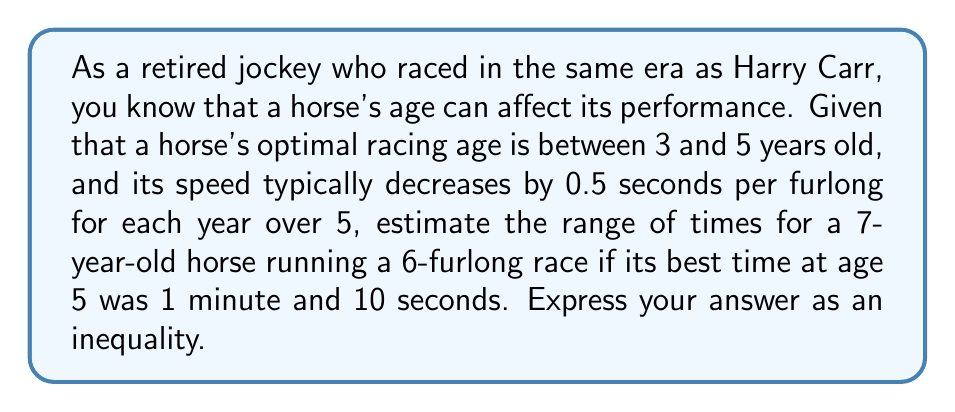What is the answer to this math problem? Let's approach this step-by-step:

1) First, we need to convert the original time to seconds:
   1 minute and 10 seconds = 70 seconds

2) The horse is now 2 years older than its optimal racing age of 5.

3) For each year over 5, the horse's speed decreases by 0.5 seconds per furlong.

4) The race is 6 furlongs long, so for each year over 5, we add:
   $0.5 \text{ seconds} \times 6 \text{ furlongs} = 3 \text{ seconds}$

5) Since the horse is 2 years over the optimal age, we add:
   $3 \text{ seconds} \times 2 \text{ years} = 6 \text{ seconds}$

6) Therefore, the horse's new time will be at least:
   $70 \text{ seconds} + 6 \text{ seconds} = 76 \text{ seconds}$

7) To account for possible variations in performance, we can estimate that the horse's time could be up to 2 seconds slower than this minimum.

8) So, the range of times can be expressed as:
   $76 \leq t \leq 78$, where $t$ is the time in seconds.
Answer: $76 \leq t \leq 78$ 